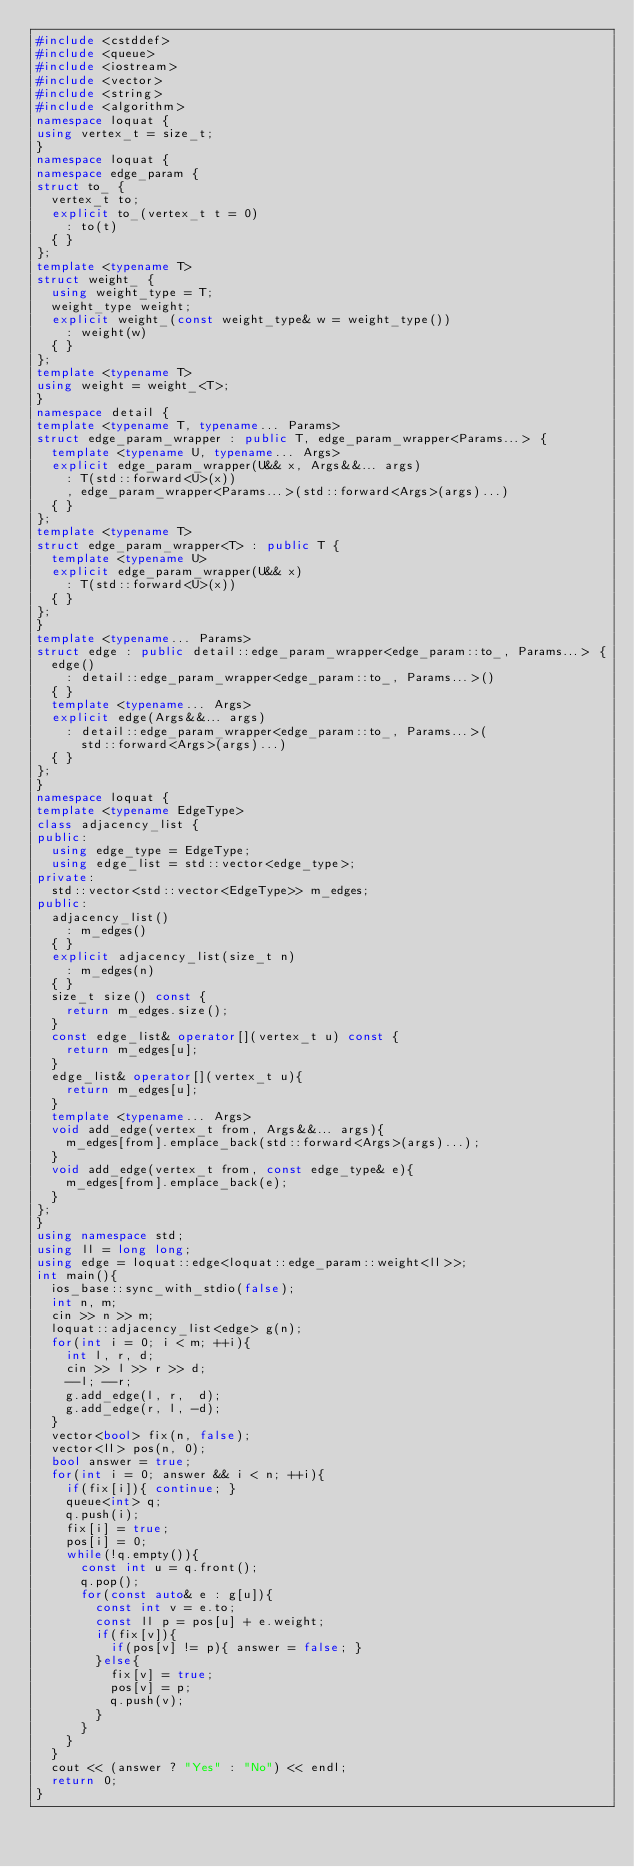<code> <loc_0><loc_0><loc_500><loc_500><_C++_>#include <cstddef>
#include <queue>
#include <iostream>
#include <vector>
#include <string>
#include <algorithm>
namespace loquat {
using vertex_t = size_t;
}
namespace loquat {
namespace edge_param {
struct to_ {
	vertex_t to;
	explicit to_(vertex_t t = 0)
		: to(t)
	{ }
};
template <typename T>
struct weight_ {
	using weight_type = T;
	weight_type weight;
	explicit weight_(const weight_type& w = weight_type())
		: weight(w)
	{ }
};
template <typename T>
using weight = weight_<T>;
}
namespace detail {
template <typename T, typename... Params>
struct edge_param_wrapper : public T, edge_param_wrapper<Params...> {
	template <typename U, typename... Args>
	explicit edge_param_wrapper(U&& x, Args&&... args)
		: T(std::forward<U>(x))
		, edge_param_wrapper<Params...>(std::forward<Args>(args)...)
	{ }
};
template <typename T>
struct edge_param_wrapper<T> : public T {
	template <typename U>
	explicit edge_param_wrapper(U&& x)
		: T(std::forward<U>(x))
	{ }
};
}
template <typename... Params>
struct edge : public detail::edge_param_wrapper<edge_param::to_, Params...> {
	edge()
		: detail::edge_param_wrapper<edge_param::to_, Params...>()
	{ }
	template <typename... Args>
	explicit edge(Args&&... args)
		: detail::edge_param_wrapper<edge_param::to_, Params...>(
			std::forward<Args>(args)...)
	{ }
};
}
namespace loquat {
template <typename EdgeType>
class adjacency_list {
public:
	using edge_type = EdgeType;
	using edge_list = std::vector<edge_type>;
private:
	std::vector<std::vector<EdgeType>> m_edges;
public:
	adjacency_list()
		: m_edges()
	{ }
	explicit adjacency_list(size_t n)
		: m_edges(n)
	{ }
	size_t size() const {
		return m_edges.size();
	}
	const edge_list& operator[](vertex_t u) const {
		return m_edges[u];
	}
	edge_list& operator[](vertex_t u){
		return m_edges[u];
	}
	template <typename... Args>
	void add_edge(vertex_t from, Args&&... args){
		m_edges[from].emplace_back(std::forward<Args>(args)...);
	}
	void add_edge(vertex_t from, const edge_type& e){
		m_edges[from].emplace_back(e);
	}
};
}
using namespace std;
using ll = long long;
using edge = loquat::edge<loquat::edge_param::weight<ll>>;
int main(){
	ios_base::sync_with_stdio(false);
	int n, m;
	cin >> n >> m;
	loquat::adjacency_list<edge> g(n);
	for(int i = 0; i < m; ++i){
		int l, r, d;
		cin >> l >> r >> d;
		--l; --r;
		g.add_edge(l, r,  d);
		g.add_edge(r, l, -d);
	}
	vector<bool> fix(n, false);
	vector<ll> pos(n, 0);
	bool answer = true;
	for(int i = 0; answer && i < n; ++i){
		if(fix[i]){ continue; }
		queue<int> q;
		q.push(i);
		fix[i] = true;
		pos[i] = 0;
		while(!q.empty()){
			const int u = q.front();
			q.pop();
			for(const auto& e : g[u]){
				const int v = e.to;
				const ll p = pos[u] + e.weight;
				if(fix[v]){
					if(pos[v] != p){ answer = false; }
				}else{
					fix[v] = true;
					pos[v] = p;
					q.push(v);
				}
			}
		}
	}
	cout << (answer ? "Yes" : "No") << endl;
	return 0;
}
</code> 